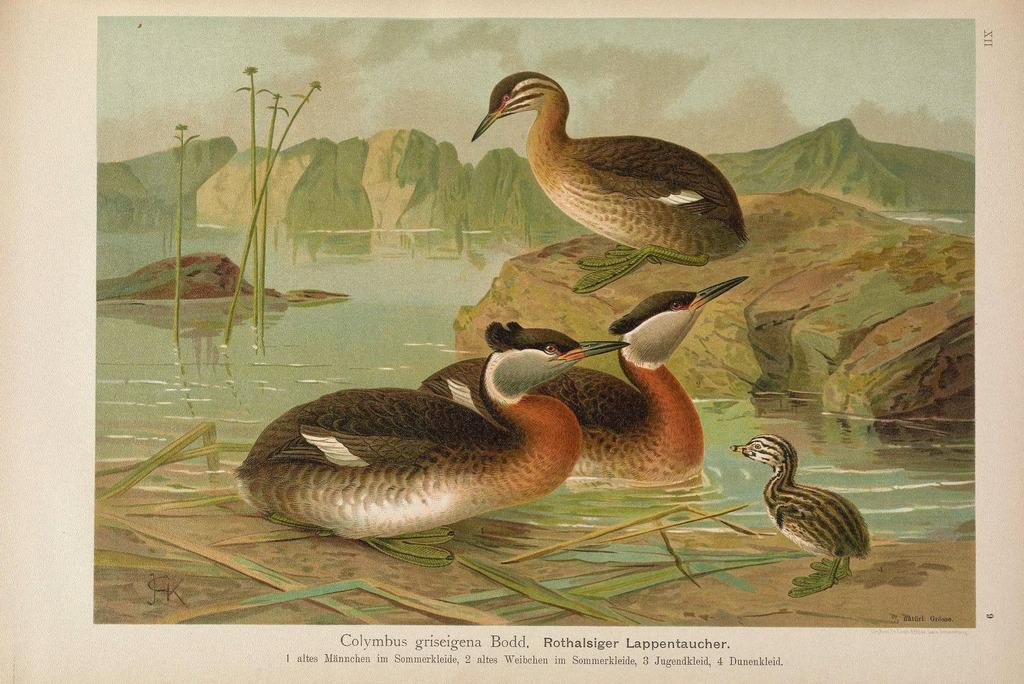What animals can be seen in the image? There is a picture of some birds in the image. What type of natural feature is present in the image? There is a water body in the image. What geological feature is visible in the image? There is a rock in the image. What type of vegetation is present in the image? There are plants in the image. What type of landscape feature is visible in the image? There are hills in the image. What part of the sky is visible in the image? There is sky visible in the image. What is written at the bottom of the image? There is some text at the bottom of the image. What type of trousers are the birds wearing in the image? There are no birds wearing trousers in the image; they are depicted as birds without clothing. What type of top is the water body wearing in the image? There is no top present in the image; the water body is a natural feature without clothing. 